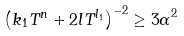<formula> <loc_0><loc_0><loc_500><loc_500>\left ( k _ { 1 } T ^ { n } + 2 l T ^ { l _ { 1 } } \right ) ^ { - 2 } \geq { 3 \alpha } ^ { 2 }</formula> 